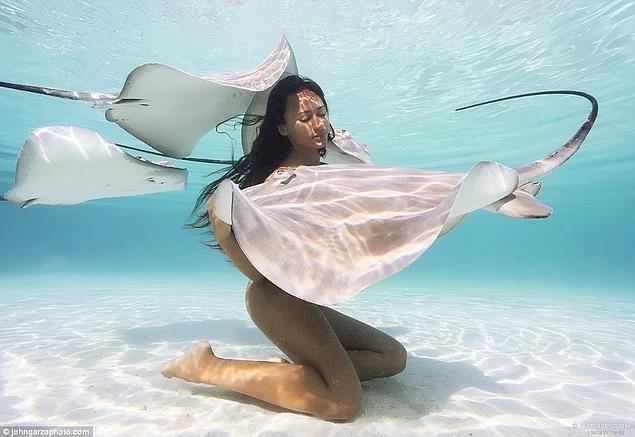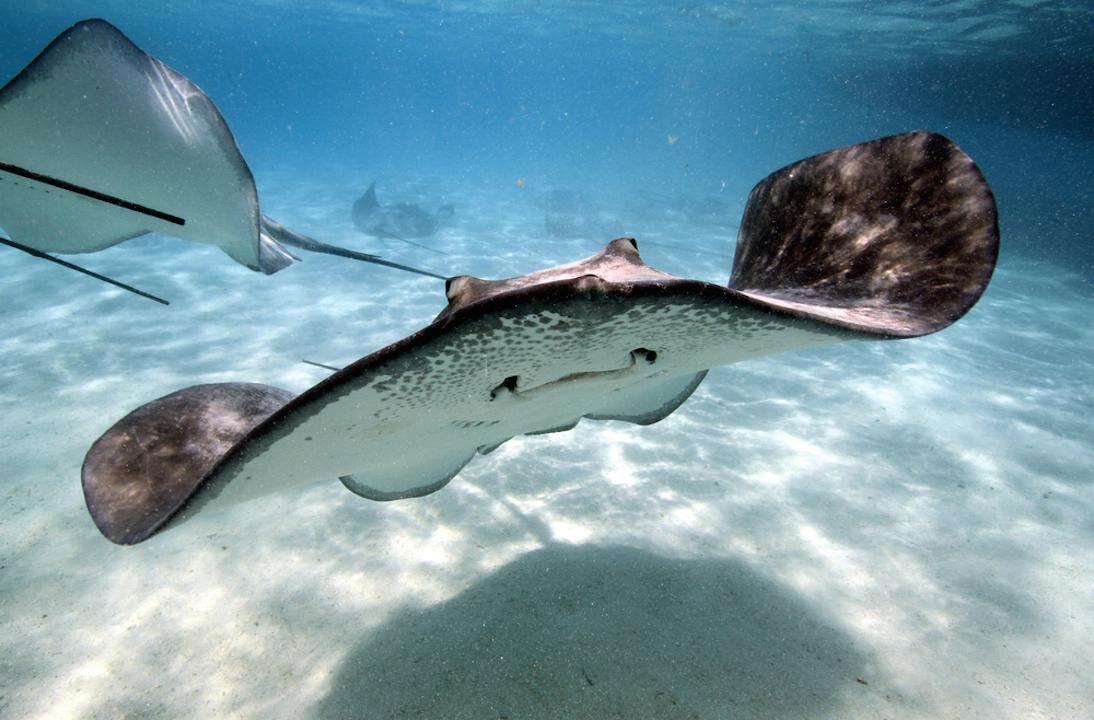The first image is the image on the left, the second image is the image on the right. Examine the images to the left and right. Is the description "In the left photo, there is a woman kneeling on the ocean floor touching a manta ray." accurate? Answer yes or no. Yes. 